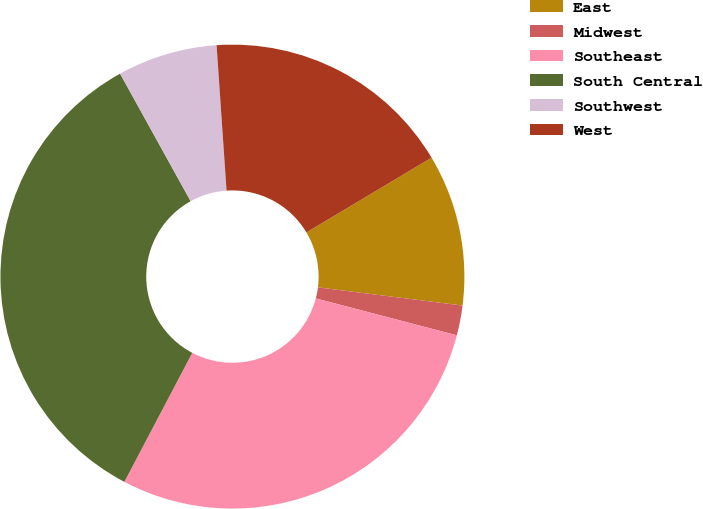Convert chart to OTSL. <chart><loc_0><loc_0><loc_500><loc_500><pie_chart><fcel>East<fcel>Midwest<fcel>Southeast<fcel>South Central<fcel>Southwest<fcel>West<nl><fcel>10.56%<fcel>2.08%<fcel>28.64%<fcel>34.24%<fcel>6.96%<fcel>17.52%<nl></chart> 